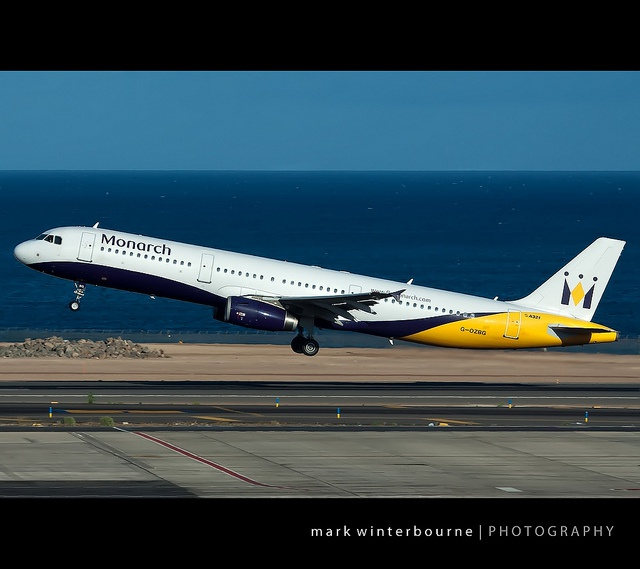Describe the objects in this image and their specific colors. I can see a airplane in black, lightgray, navy, and gold tones in this image. 